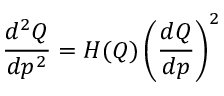Convert formula to latex. <formula><loc_0><loc_0><loc_500><loc_500>{ \frac { d ^ { 2 } Q } { d p ^ { 2 } } } = H ( Q ) \left ( { \frac { d Q } { d p } } \right ) ^ { 2 }</formula> 